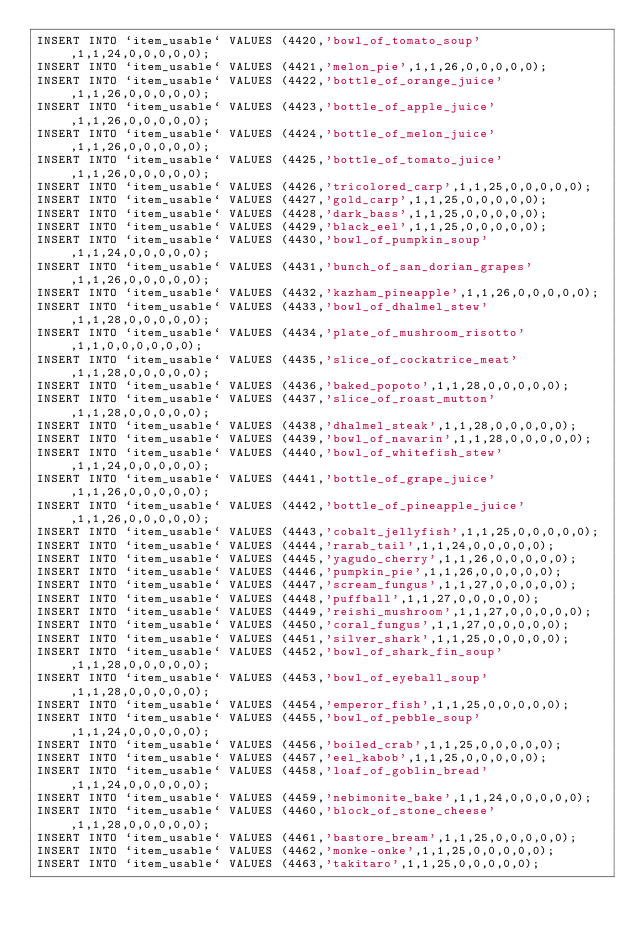Convert code to text. <code><loc_0><loc_0><loc_500><loc_500><_SQL_>INSERT INTO `item_usable` VALUES (4420,'bowl_of_tomato_soup',1,1,24,0,0,0,0,0);
INSERT INTO `item_usable` VALUES (4421,'melon_pie',1,1,26,0,0,0,0,0);
INSERT INTO `item_usable` VALUES (4422,'bottle_of_orange_juice',1,1,26,0,0,0,0,0);
INSERT INTO `item_usable` VALUES (4423,'bottle_of_apple_juice',1,1,26,0,0,0,0,0);
INSERT INTO `item_usable` VALUES (4424,'bottle_of_melon_juice',1,1,26,0,0,0,0,0);
INSERT INTO `item_usable` VALUES (4425,'bottle_of_tomato_juice',1,1,26,0,0,0,0,0);
INSERT INTO `item_usable` VALUES (4426,'tricolored_carp',1,1,25,0,0,0,0,0);
INSERT INTO `item_usable` VALUES (4427,'gold_carp',1,1,25,0,0,0,0,0);
INSERT INTO `item_usable` VALUES (4428,'dark_bass',1,1,25,0,0,0,0,0);
INSERT INTO `item_usable` VALUES (4429,'black_eel',1,1,25,0,0,0,0,0);
INSERT INTO `item_usable` VALUES (4430,'bowl_of_pumpkin_soup',1,1,24,0,0,0,0,0);
INSERT INTO `item_usable` VALUES (4431,'bunch_of_san_dorian_grapes',1,1,26,0,0,0,0,0);
INSERT INTO `item_usable` VALUES (4432,'kazham_pineapple',1,1,26,0,0,0,0,0);
INSERT INTO `item_usable` VALUES (4433,'bowl_of_dhalmel_stew',1,1,28,0,0,0,0,0);
INSERT INTO `item_usable` VALUES (4434,'plate_of_mushroom_risotto',1,1,0,0,0,0,0,0);
INSERT INTO `item_usable` VALUES (4435,'slice_of_cockatrice_meat',1,1,28,0,0,0,0,0);
INSERT INTO `item_usable` VALUES (4436,'baked_popoto',1,1,28,0,0,0,0,0);
INSERT INTO `item_usable` VALUES (4437,'slice_of_roast_mutton',1,1,28,0,0,0,0,0);
INSERT INTO `item_usable` VALUES (4438,'dhalmel_steak',1,1,28,0,0,0,0,0);
INSERT INTO `item_usable` VALUES (4439,'bowl_of_navarin',1,1,28,0,0,0,0,0);
INSERT INTO `item_usable` VALUES (4440,'bowl_of_whitefish_stew',1,1,24,0,0,0,0,0);
INSERT INTO `item_usable` VALUES (4441,'bottle_of_grape_juice',1,1,26,0,0,0,0,0);
INSERT INTO `item_usable` VALUES (4442,'bottle_of_pineapple_juice',1,1,26,0,0,0,0,0);
INSERT INTO `item_usable` VALUES (4443,'cobalt_jellyfish',1,1,25,0,0,0,0,0);
INSERT INTO `item_usable` VALUES (4444,'rarab_tail',1,1,24,0,0,0,0,0);
INSERT INTO `item_usable` VALUES (4445,'yagudo_cherry',1,1,26,0,0,0,0,0);
INSERT INTO `item_usable` VALUES (4446,'pumpkin_pie',1,1,26,0,0,0,0,0);
INSERT INTO `item_usable` VALUES (4447,'scream_fungus',1,1,27,0,0,0,0,0);
INSERT INTO `item_usable` VALUES (4448,'puffball',1,1,27,0,0,0,0,0);
INSERT INTO `item_usable` VALUES (4449,'reishi_mushroom',1,1,27,0,0,0,0,0);
INSERT INTO `item_usable` VALUES (4450,'coral_fungus',1,1,27,0,0,0,0,0);
INSERT INTO `item_usable` VALUES (4451,'silver_shark',1,1,25,0,0,0,0,0);
INSERT INTO `item_usable` VALUES (4452,'bowl_of_shark_fin_soup',1,1,28,0,0,0,0,0);
INSERT INTO `item_usable` VALUES (4453,'bowl_of_eyeball_soup',1,1,28,0,0,0,0,0);
INSERT INTO `item_usable` VALUES (4454,'emperor_fish',1,1,25,0,0,0,0,0);
INSERT INTO `item_usable` VALUES (4455,'bowl_of_pebble_soup',1,1,24,0,0,0,0,0);
INSERT INTO `item_usable` VALUES (4456,'boiled_crab',1,1,25,0,0,0,0,0);
INSERT INTO `item_usable` VALUES (4457,'eel_kabob',1,1,25,0,0,0,0,0);
INSERT INTO `item_usable` VALUES (4458,'loaf_of_goblin_bread',1,1,24,0,0,0,0,0);
INSERT INTO `item_usable` VALUES (4459,'nebimonite_bake',1,1,24,0,0,0,0,0);
INSERT INTO `item_usable` VALUES (4460,'block_of_stone_cheese',1,1,28,0,0,0,0,0);
INSERT INTO `item_usable` VALUES (4461,'bastore_bream',1,1,25,0,0,0,0,0);
INSERT INTO `item_usable` VALUES (4462,'monke-onke',1,1,25,0,0,0,0,0);
INSERT INTO `item_usable` VALUES (4463,'takitaro',1,1,25,0,0,0,0,0);</code> 